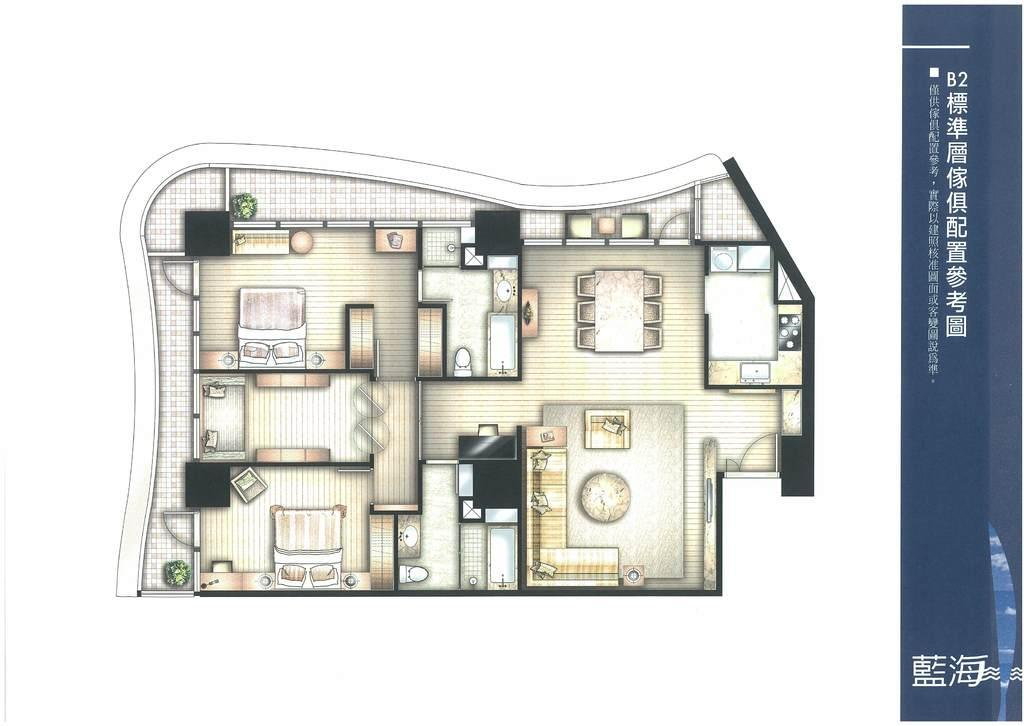What type of diagram is shown in the image? The image contains a floor plan. Where is the text located in the image? The text is on the right side of the image. What type of hat is the doll wearing in the image? There is no doll or hat present in the image. 